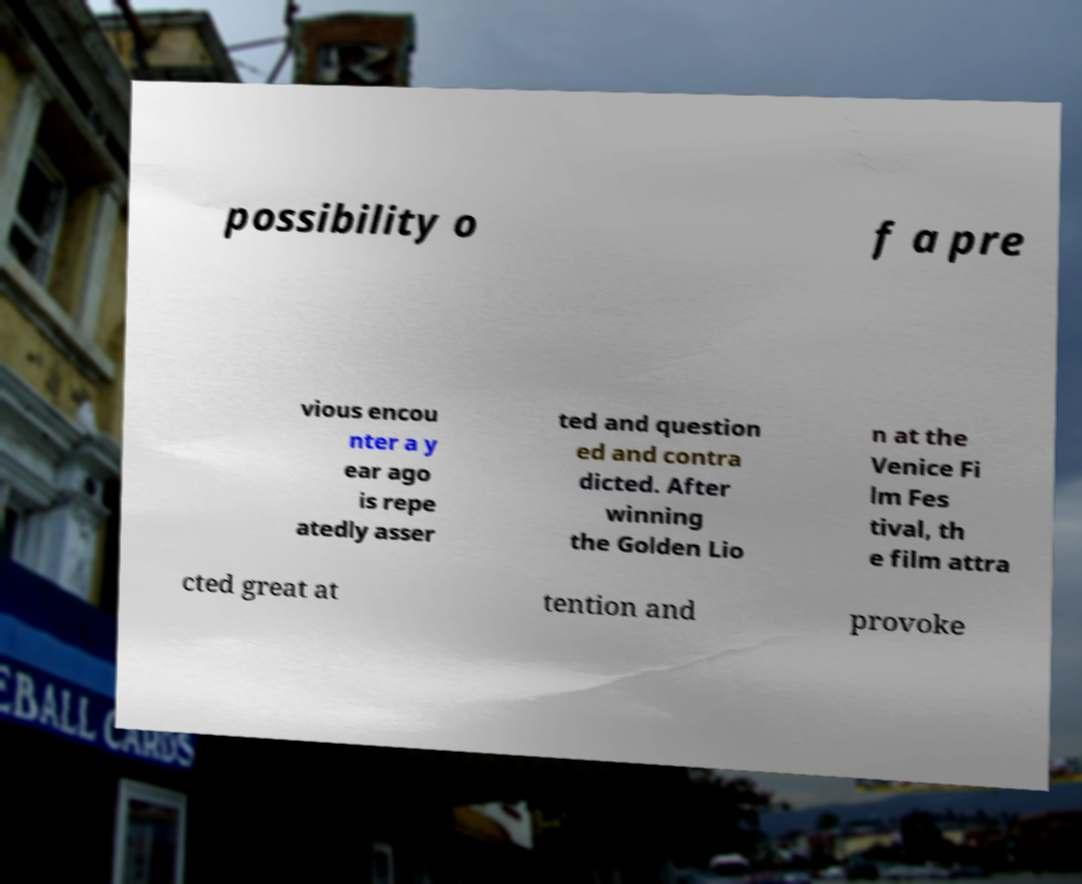Could you assist in decoding the text presented in this image and type it out clearly? possibility o f a pre vious encou nter a y ear ago is repe atedly asser ted and question ed and contra dicted. After winning the Golden Lio n at the Venice Fi lm Fes tival, th e film attra cted great at tention and provoke 